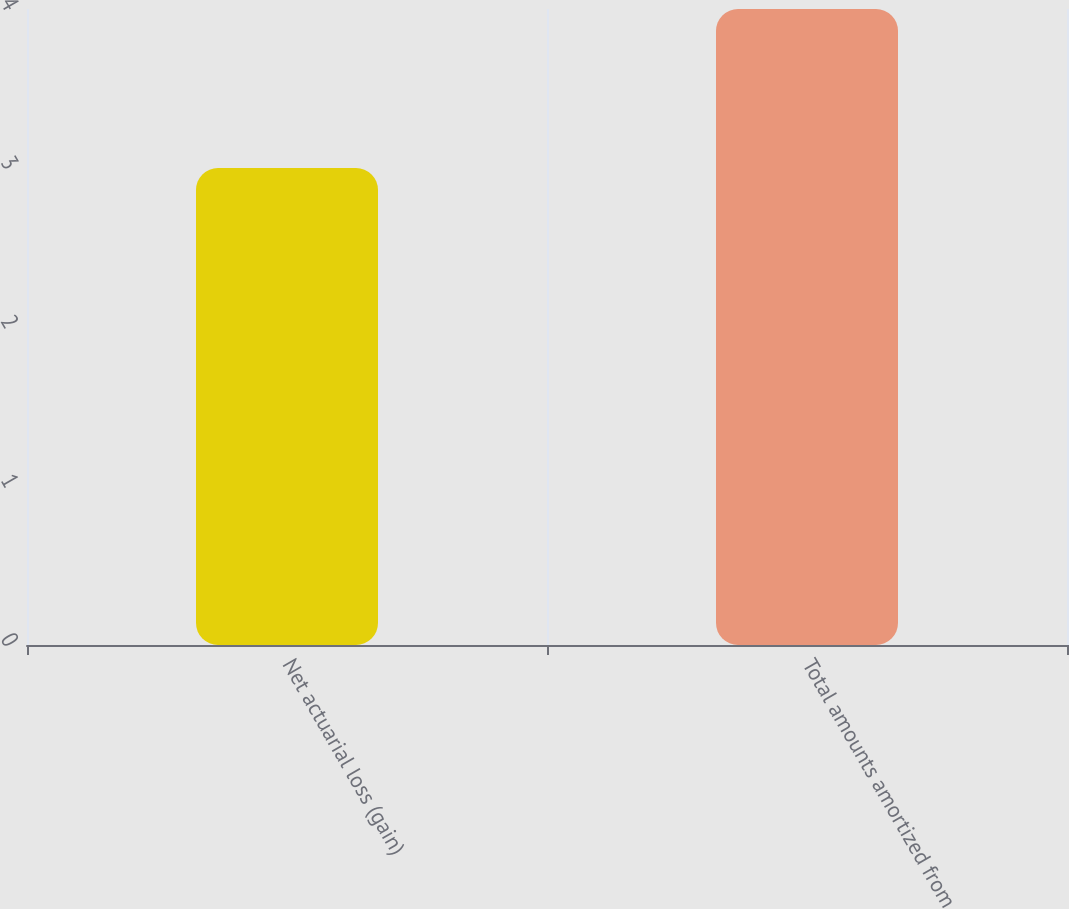Convert chart to OTSL. <chart><loc_0><loc_0><loc_500><loc_500><bar_chart><fcel>Net actuarial loss (gain)<fcel>Total amounts amortized from<nl><fcel>3<fcel>4<nl></chart> 